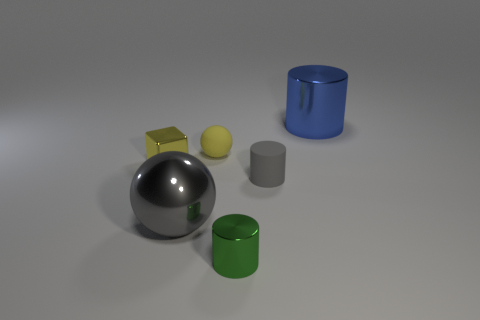How many red rubber objects are there?
Your answer should be very brief. 0. Does the tiny metallic thing that is behind the tiny gray object have the same color as the rubber thing that is behind the tiny gray object?
Provide a short and direct response. Yes. There is a blue metallic thing; how many large shiny things are in front of it?
Provide a succinct answer. 1. There is a large thing that is the same color as the tiny rubber cylinder; what is it made of?
Your answer should be very brief. Metal. Is there a gray object that has the same shape as the tiny yellow rubber thing?
Give a very brief answer. Yes. Is the sphere that is behind the big gray sphere made of the same material as the small cylinder behind the gray metal object?
Your response must be concise. Yes. There is a shiny object that is behind the tiny shiny object to the left of the small thing behind the yellow metal cube; what is its size?
Your response must be concise. Large. What is the material of the green cylinder that is the same size as the gray rubber object?
Offer a very short reply. Metal. Is there a blue object of the same size as the metallic sphere?
Provide a short and direct response. Yes. Is the shape of the tiny yellow metal thing the same as the small yellow rubber thing?
Offer a very short reply. No. 